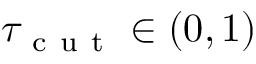Convert formula to latex. <formula><loc_0><loc_0><loc_500><loc_500>\tau _ { c u t } \in ( 0 , 1 )</formula> 